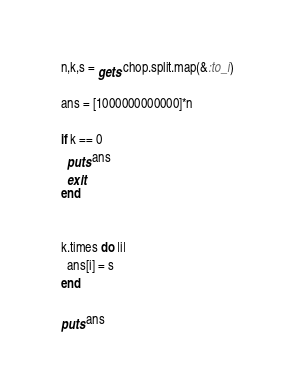Convert code to text. <code><loc_0><loc_0><loc_500><loc_500><_Ruby_>n,k,s = gets.chop.split.map(&:to_i)

ans = [1000000000000]*n

if k == 0
  puts ans
  exit
end


k.times do |i|
  ans[i] = s
end

puts ans
</code> 